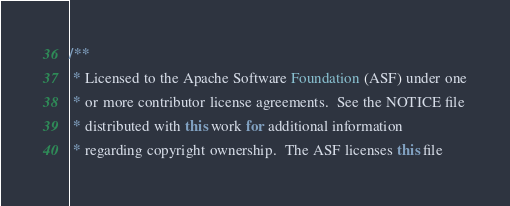<code> <loc_0><loc_0><loc_500><loc_500><_Java_>/**
 * Licensed to the Apache Software Foundation (ASF) under one
 * or more contributor license agreements.  See the NOTICE file
 * distributed with this work for additional information
 * regarding copyright ownership.  The ASF licenses this file</code> 